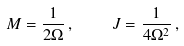<formula> <loc_0><loc_0><loc_500><loc_500>M = \frac { 1 } { 2 \Omega } \, , \quad J = \frac { 1 } { 4 \Omega ^ { 2 } } \, ,</formula> 